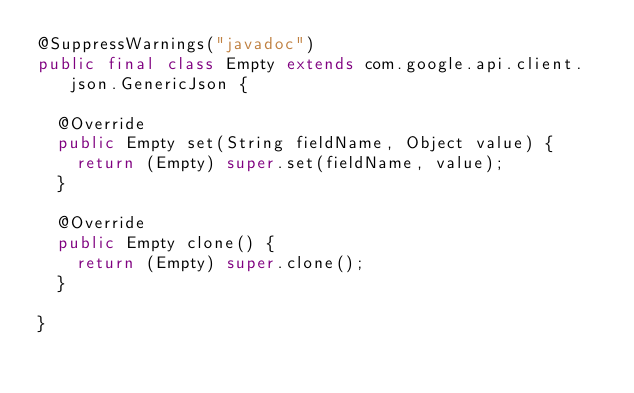<code> <loc_0><loc_0><loc_500><loc_500><_Java_>@SuppressWarnings("javadoc")
public final class Empty extends com.google.api.client.json.GenericJson {

  @Override
  public Empty set(String fieldName, Object value) {
    return (Empty) super.set(fieldName, value);
  }

  @Override
  public Empty clone() {
    return (Empty) super.clone();
  }

}
</code> 